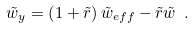<formula> <loc_0><loc_0><loc_500><loc_500>\tilde { w } _ { y } = \left ( 1 + \tilde { r } \right ) \tilde { w } _ { e f f } - \tilde { r } \tilde { w } \ .</formula> 